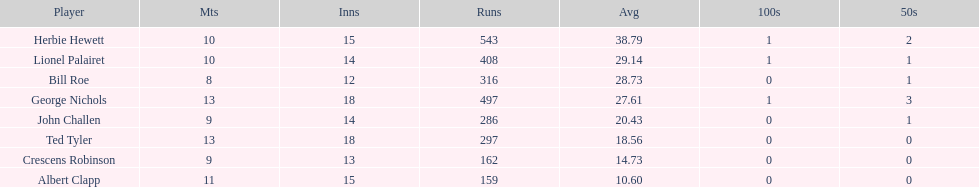How many innings did bill and ted have in total? 30. 